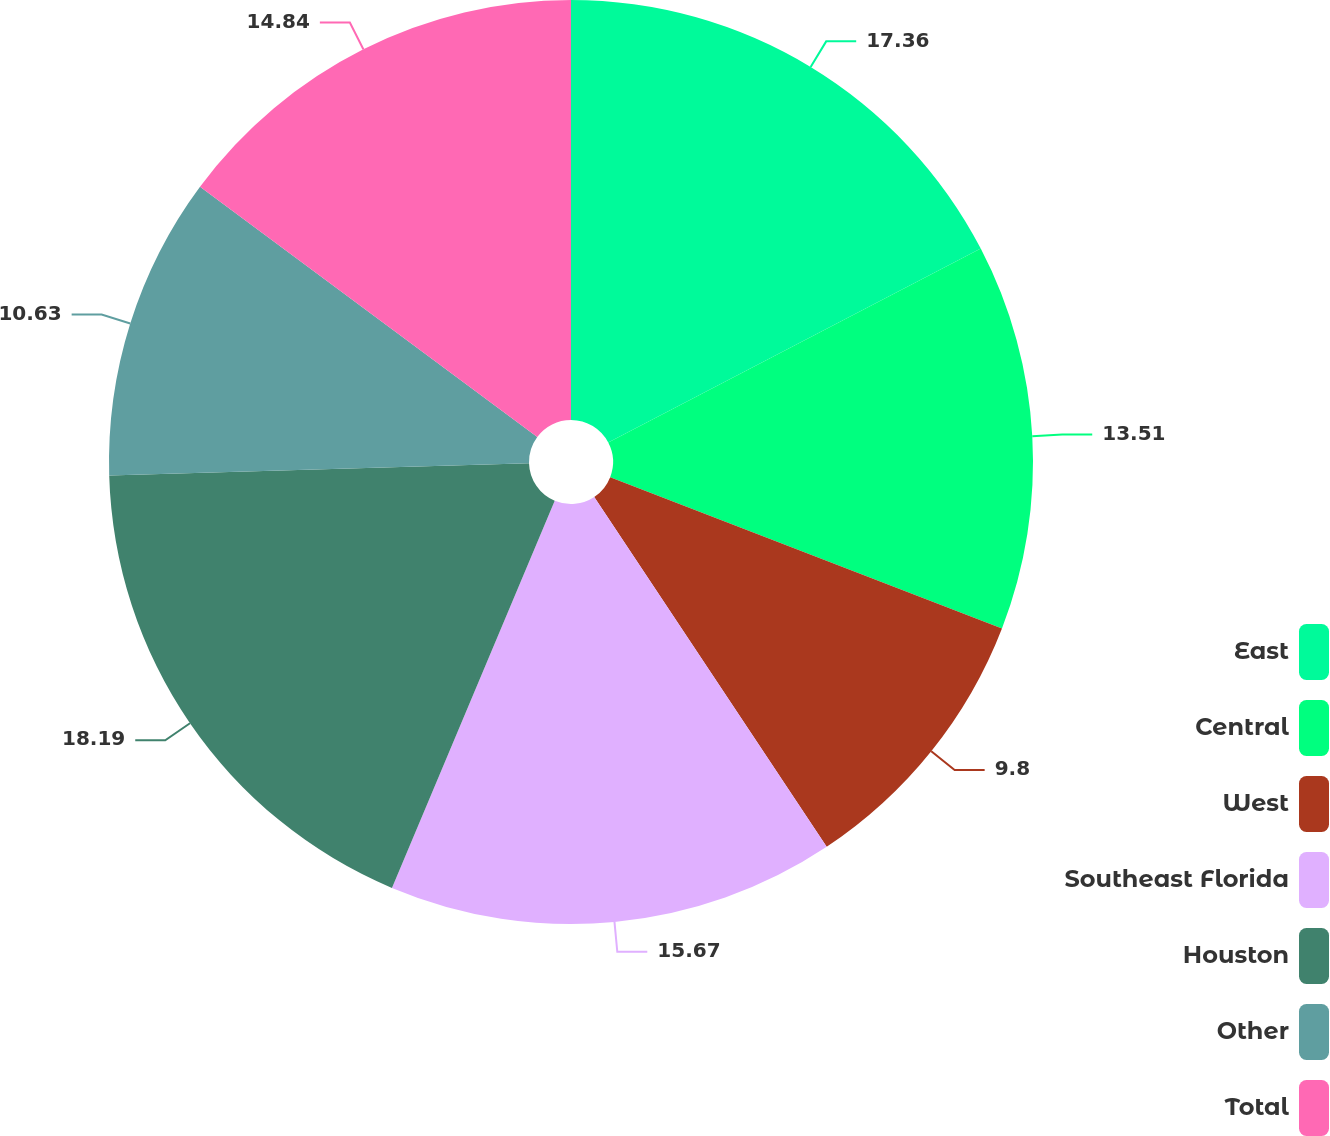<chart> <loc_0><loc_0><loc_500><loc_500><pie_chart><fcel>East<fcel>Central<fcel>West<fcel>Southeast Florida<fcel>Houston<fcel>Other<fcel>Total<nl><fcel>17.36%<fcel>13.51%<fcel>9.8%<fcel>15.67%<fcel>18.2%<fcel>10.63%<fcel>14.84%<nl></chart> 